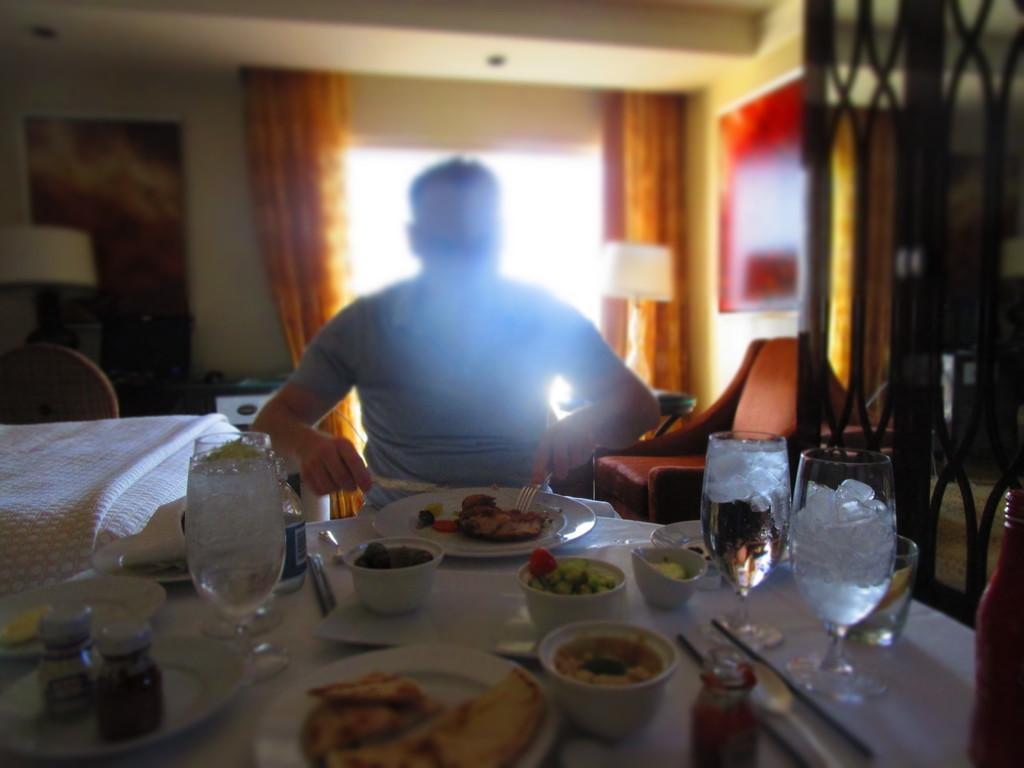Describe this image in one or two sentences. The person wearing blue shirt is sitting in front of a table which contains some eatables on it and there is a bed beside him and there is a window behind him. 